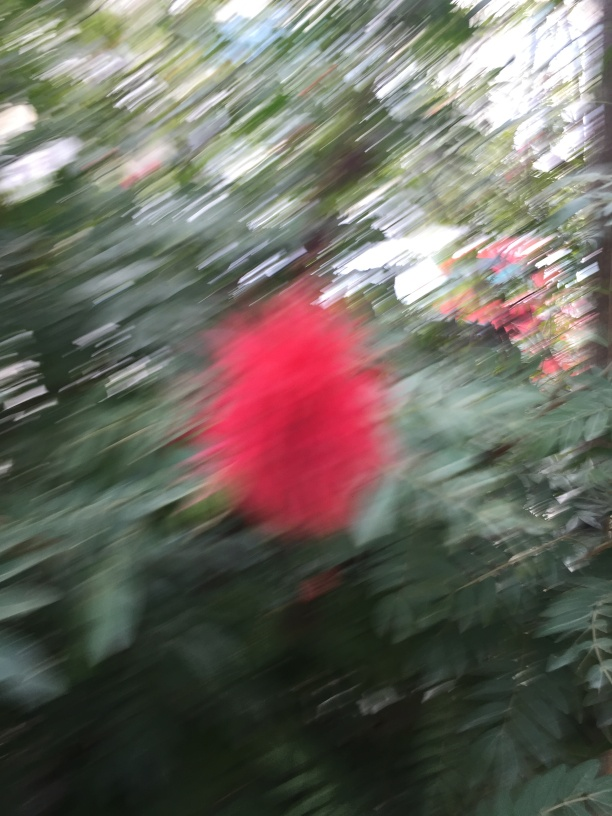Are there any quality issues with this image? The image appears to be blurred and out of focus, which compromises the clarity and detail of the subject. Additionally, there is motion blur, indicating that both the camera and the object were moving during the shot. These factors significantly affect the image quality and could impede viewers' full appreciation of the scene. 